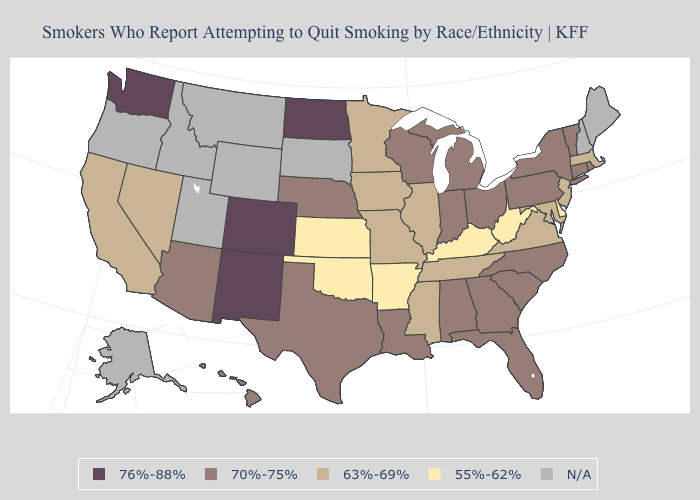Name the states that have a value in the range 63%-69%?
Answer briefly. California, Illinois, Iowa, Maryland, Massachusetts, Minnesota, Mississippi, Missouri, Nevada, New Jersey, Tennessee, Virginia. Which states have the lowest value in the South?
Answer briefly. Arkansas, Delaware, Kentucky, Oklahoma, West Virginia. Which states have the highest value in the USA?
Be succinct. Colorado, New Mexico, North Dakota, Washington. Name the states that have a value in the range N/A?
Short answer required. Alaska, Idaho, Maine, Montana, New Hampshire, Oregon, South Dakota, Utah, Wyoming. Does Mississippi have the highest value in the South?
Keep it brief. No. What is the value of Wyoming?
Quick response, please. N/A. Does Washington have the lowest value in the West?
Be succinct. No. Name the states that have a value in the range N/A?
Keep it brief. Alaska, Idaho, Maine, Montana, New Hampshire, Oregon, South Dakota, Utah, Wyoming. Does the map have missing data?
Write a very short answer. Yes. What is the value of Georgia?
Answer briefly. 70%-75%. Name the states that have a value in the range N/A?
Short answer required. Alaska, Idaho, Maine, Montana, New Hampshire, Oregon, South Dakota, Utah, Wyoming. Name the states that have a value in the range 63%-69%?
Answer briefly. California, Illinois, Iowa, Maryland, Massachusetts, Minnesota, Mississippi, Missouri, Nevada, New Jersey, Tennessee, Virginia. Among the states that border Illinois , does Iowa have the highest value?
Short answer required. No. 